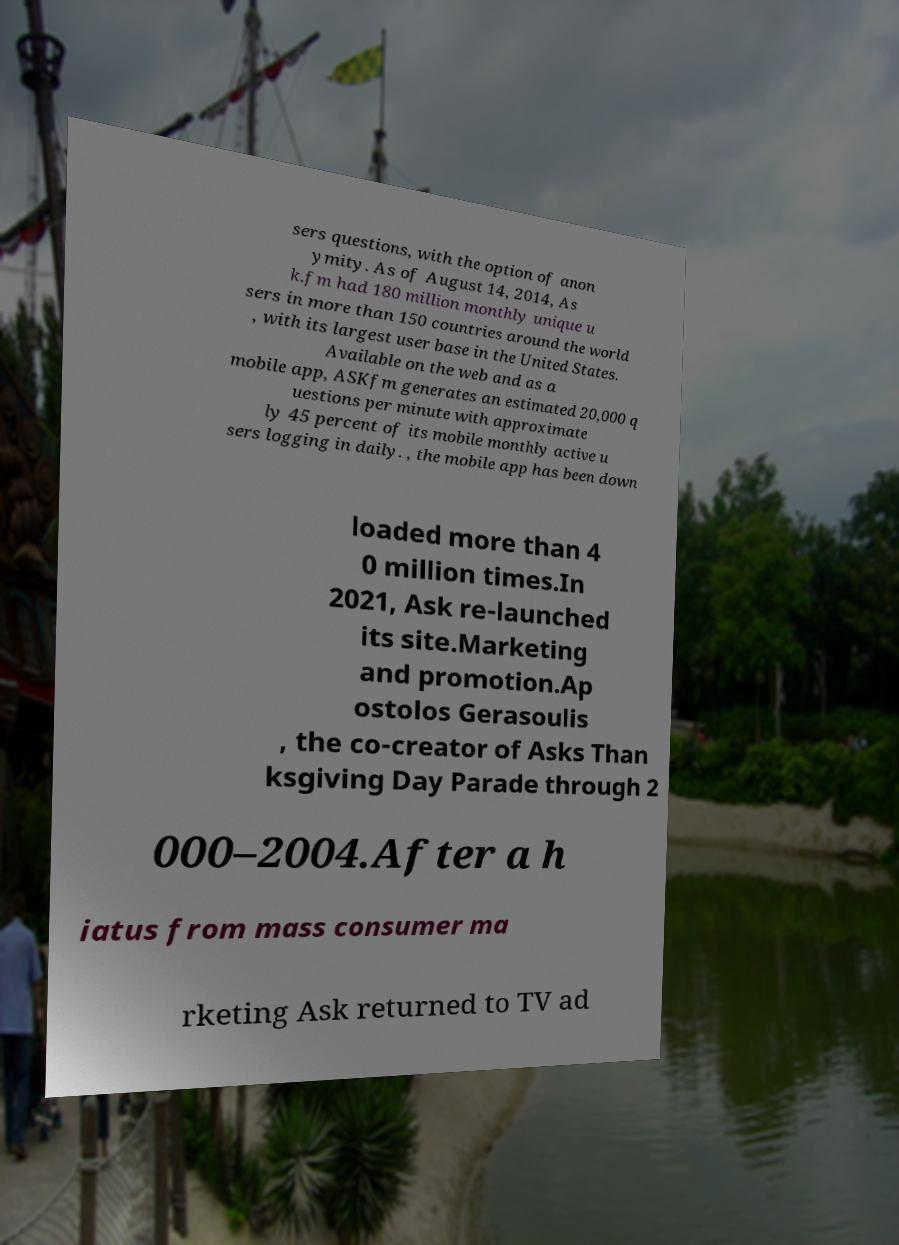Could you assist in decoding the text presented in this image and type it out clearly? sers questions, with the option of anon ymity. As of August 14, 2014, As k.fm had 180 million monthly unique u sers in more than 150 countries around the world , with its largest user base in the United States. Available on the web and as a mobile app, ASKfm generates an estimated 20,000 q uestions per minute with approximate ly 45 percent of its mobile monthly active u sers logging in daily. , the mobile app has been down loaded more than 4 0 million times.In 2021, Ask re-launched its site.Marketing and promotion.Ap ostolos Gerasoulis , the co-creator of Asks Than ksgiving Day Parade through 2 000–2004.After a h iatus from mass consumer ma rketing Ask returned to TV ad 